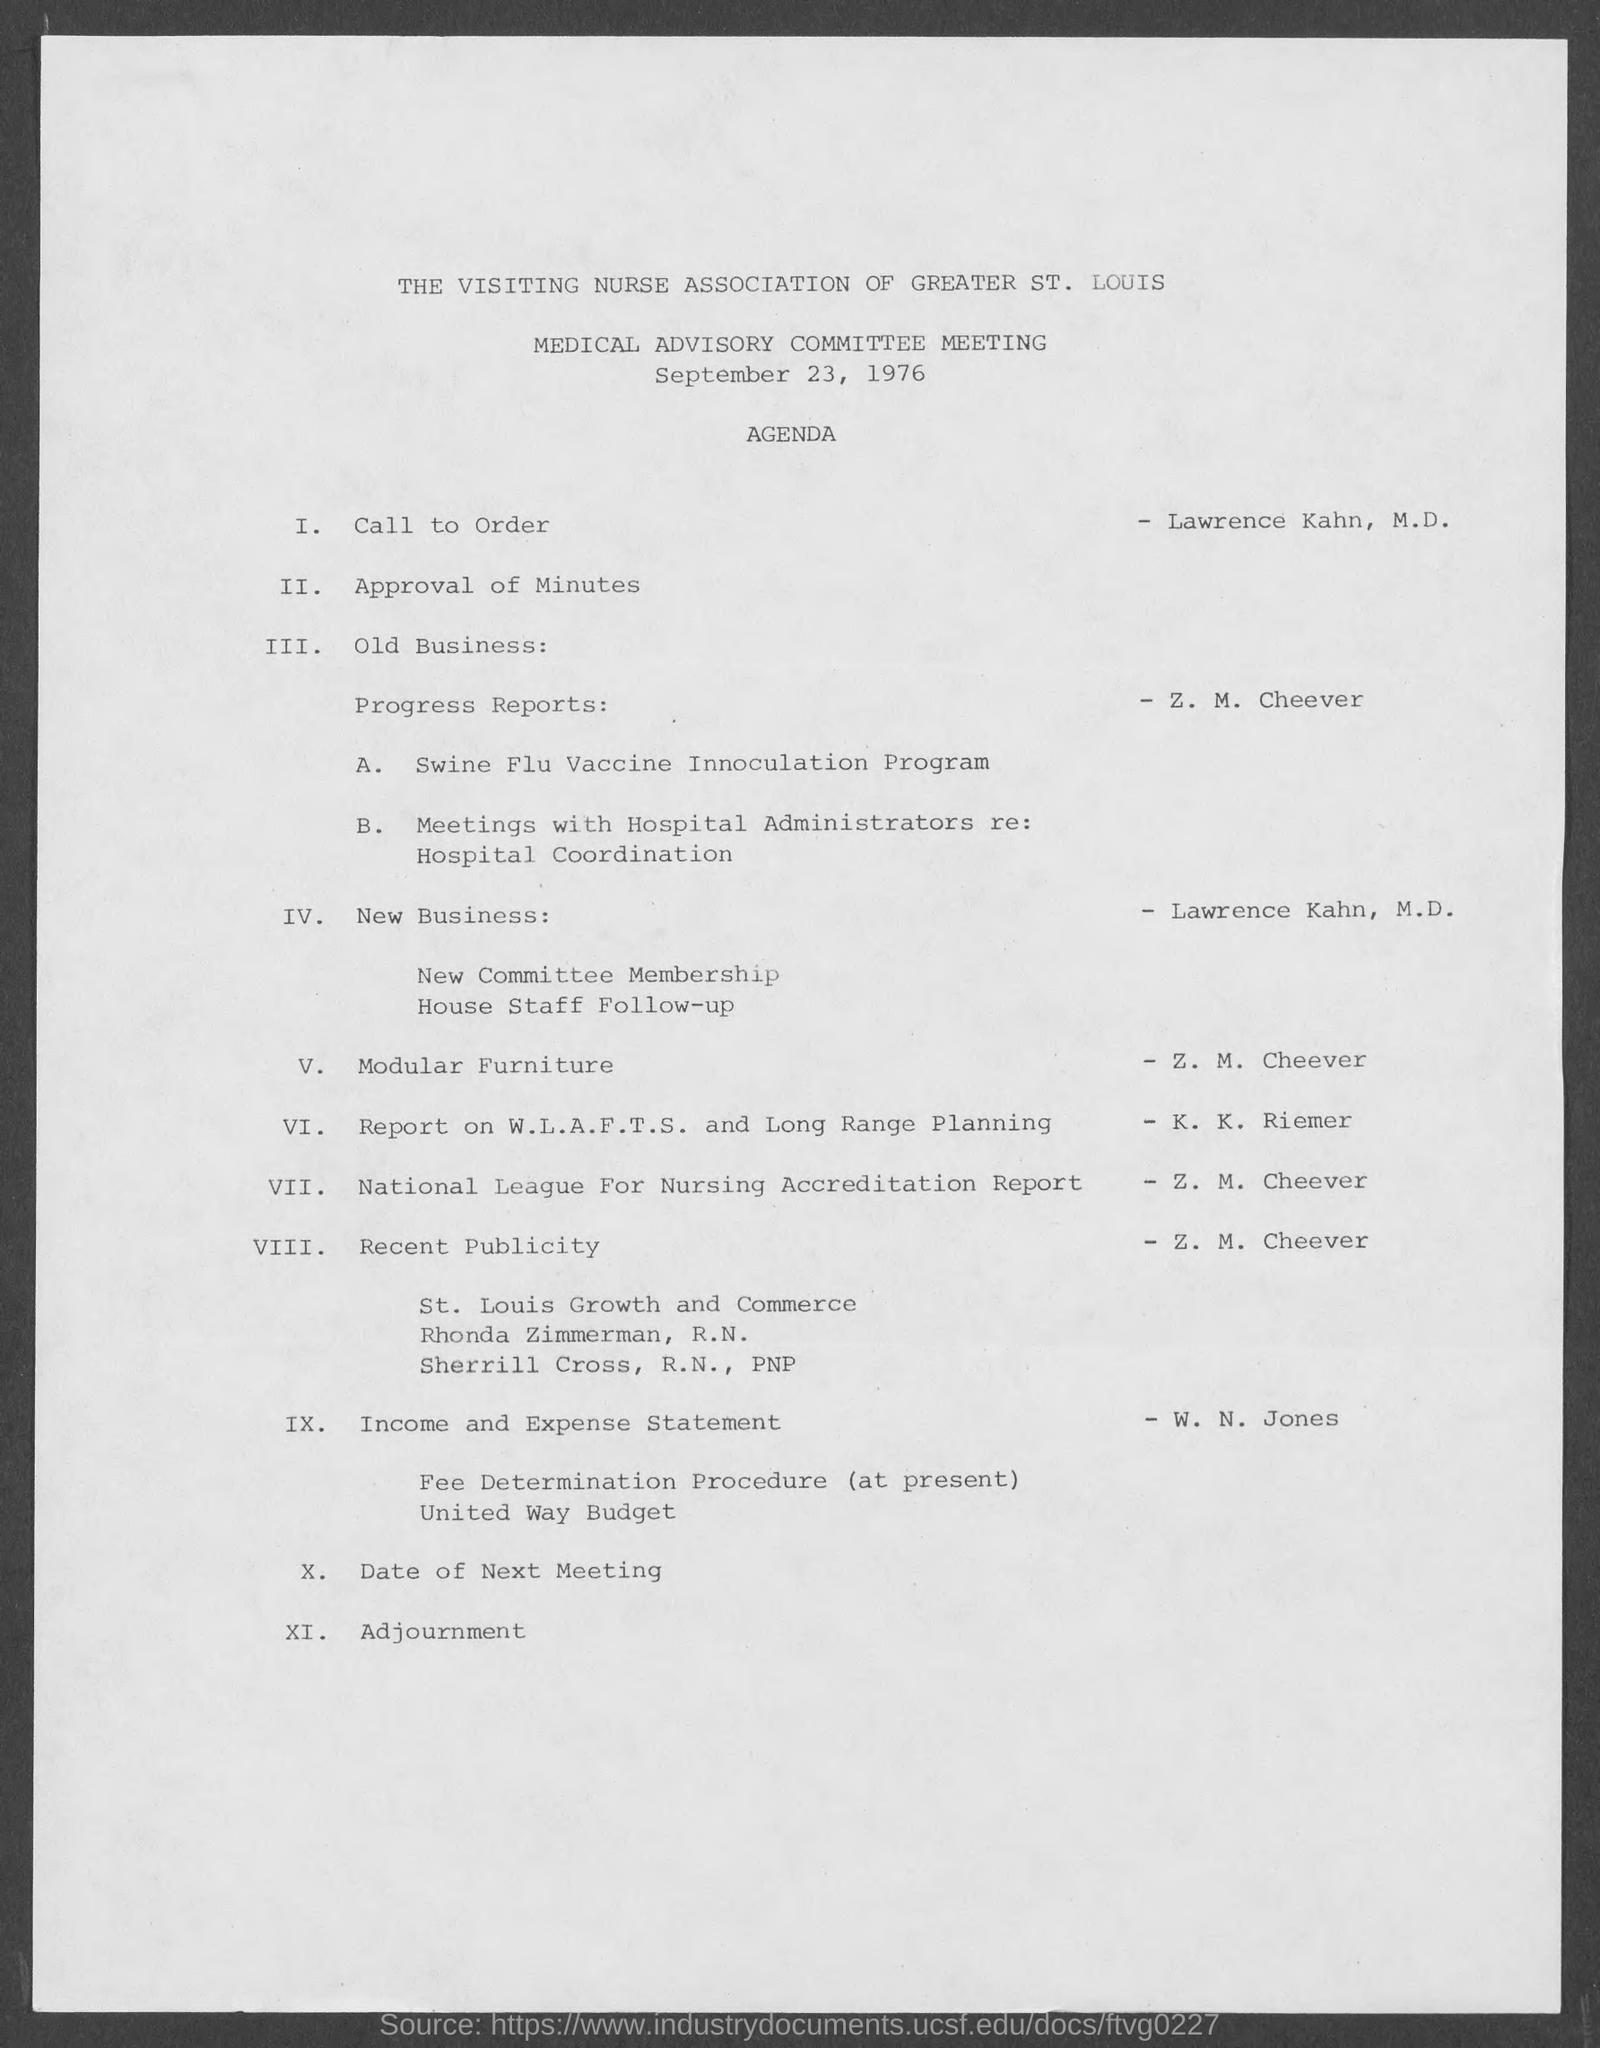Identify some key points in this picture. It was announced during the meeting that William N. Jones would be presenting the Income and Expense Statement as per the agenda. The Medical Advisory Committee Meeting was scheduled for September 23, 1976. 